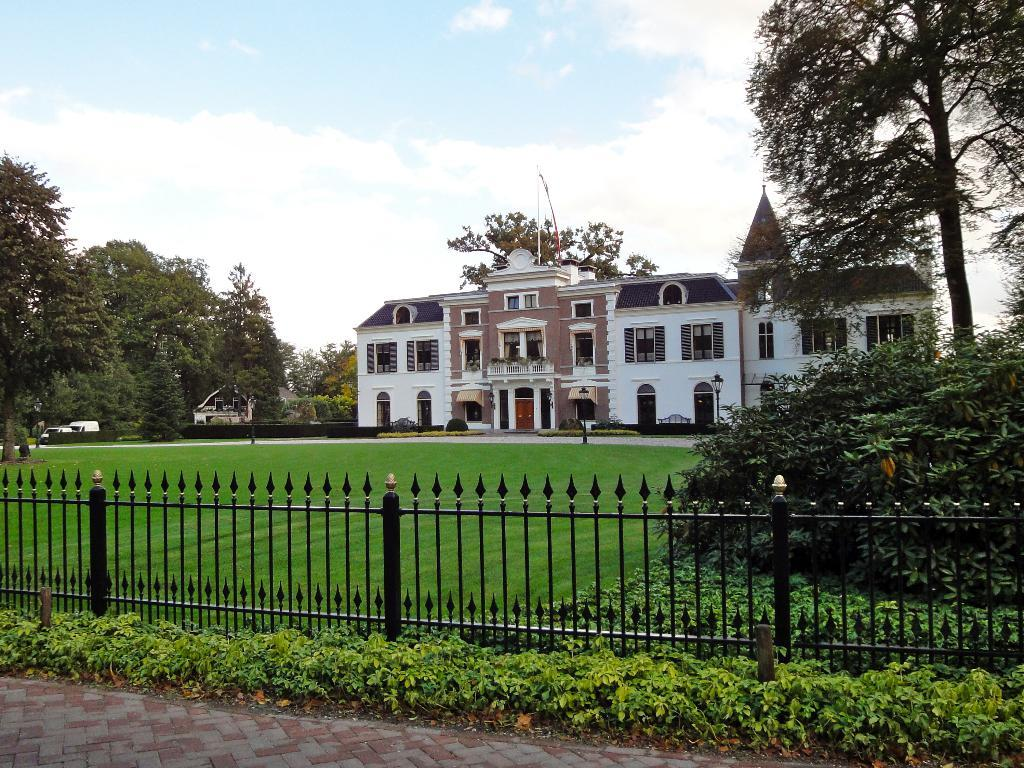What type of structures can be seen in the image? There are buildings in the image. What other elements are present in the image besides buildings? There are plants, iron grilles, and trees in the image. What can be seen in the background of the image? The sky is visible in the background of the image. What type of food is being served in the image? There is no food present in the image; it features buildings, plants, iron grilles, trees, and the sky. 